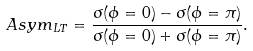Convert formula to latex. <formula><loc_0><loc_0><loc_500><loc_500>A s y m _ { L T } = \frac { \sigma ( \phi = 0 ) - \sigma ( \phi = \pi ) } { \sigma ( \phi = 0 ) + \sigma ( \phi = \pi ) } .</formula> 